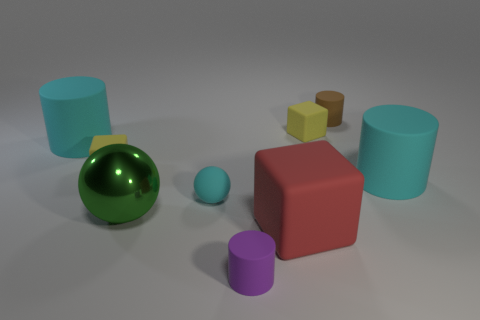How many objects are tiny rubber things in front of the red thing or cyan rubber cubes?
Give a very brief answer. 1. How many blue spheres are there?
Give a very brief answer. 0. What is the shape of the red thing that is the same material as the cyan sphere?
Your answer should be very brief. Cube. What is the size of the cyan object that is to the right of the small cube that is on the right side of the rubber ball?
Your answer should be compact. Large. What number of objects are yellow matte cubes that are right of the green thing or tiny yellow things that are left of the purple matte cylinder?
Offer a very short reply. 2. Are there fewer large green metal balls than tiny things?
Make the answer very short. Yes. What number of things are either tiny blue metal objects or cyan objects?
Provide a short and direct response. 3. Does the small purple object have the same shape as the small brown thing?
Keep it short and to the point. Yes. Is there any other thing that is the same material as the big green thing?
Give a very brief answer. No. Does the cyan rubber cylinder that is on the left side of the tiny brown thing have the same size as the cyan matte thing that is right of the small rubber sphere?
Give a very brief answer. Yes. 